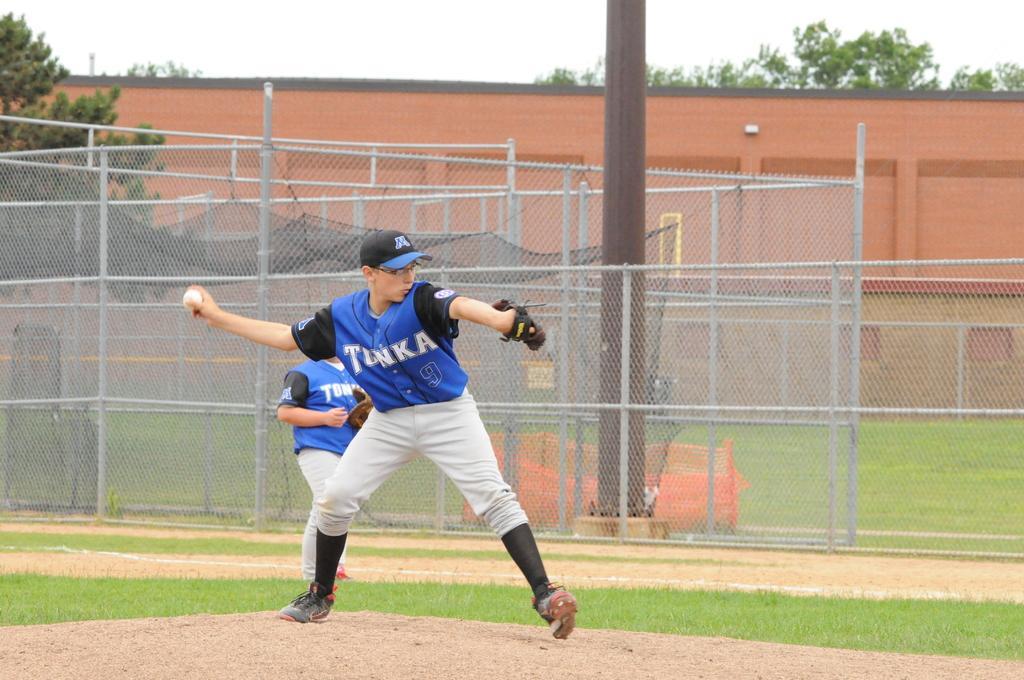Can you describe this image briefly? In this image, there are a few people. Among them, we can see a person holding some object. We can see the ground covered with grass and some objects. We can also see some poles with nets. There are a few trees. We can see the wall and the sky. 